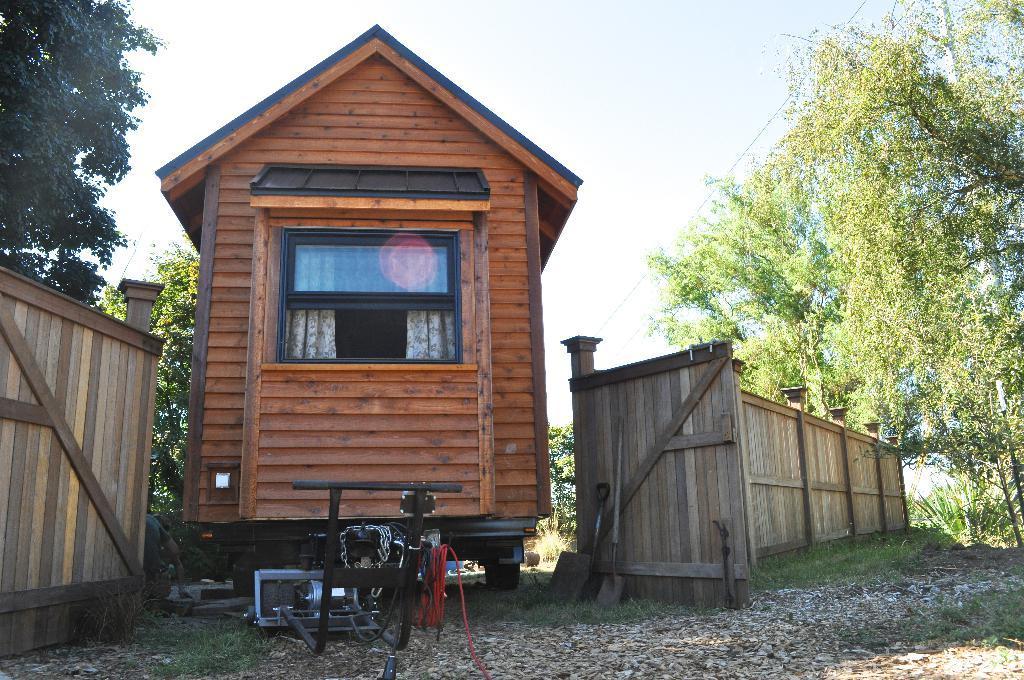In one or two sentences, can you explain what this image depicts? This image consists of a small house made up of wood. In the front, there is a window. And it has wheels. At the bottom, there is ground. On the left and right, there is a fencing made up of wood. And there are trees. At the top, there is sky. 